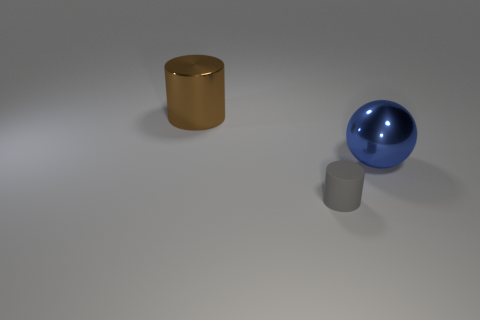What is the size of the blue sphere that is the same material as the large brown cylinder?
Give a very brief answer. Large. There is a large object that is right of the small thing; what shape is it?
Offer a very short reply. Sphere. Are there any small metallic cylinders?
Provide a succinct answer. No. What is the shape of the thing that is behind the large shiny thing that is in front of the large thing on the left side of the metal ball?
Provide a succinct answer. Cylinder. There is a large metal ball; what number of big metal objects are behind it?
Provide a succinct answer. 1. Is the material of the big blue thing behind the tiny gray thing the same as the tiny gray object?
Provide a short and direct response. No. What number of other objects are the same shape as the blue shiny thing?
Your response must be concise. 0. There is a cylinder left of the cylinder that is on the right side of the big brown shiny cylinder; how many objects are on the right side of it?
Ensure brevity in your answer.  2. What is the color of the thing left of the gray matte cylinder?
Make the answer very short. Brown. There is a brown shiny object that is the same shape as the small matte thing; what is its size?
Your answer should be very brief. Large. 